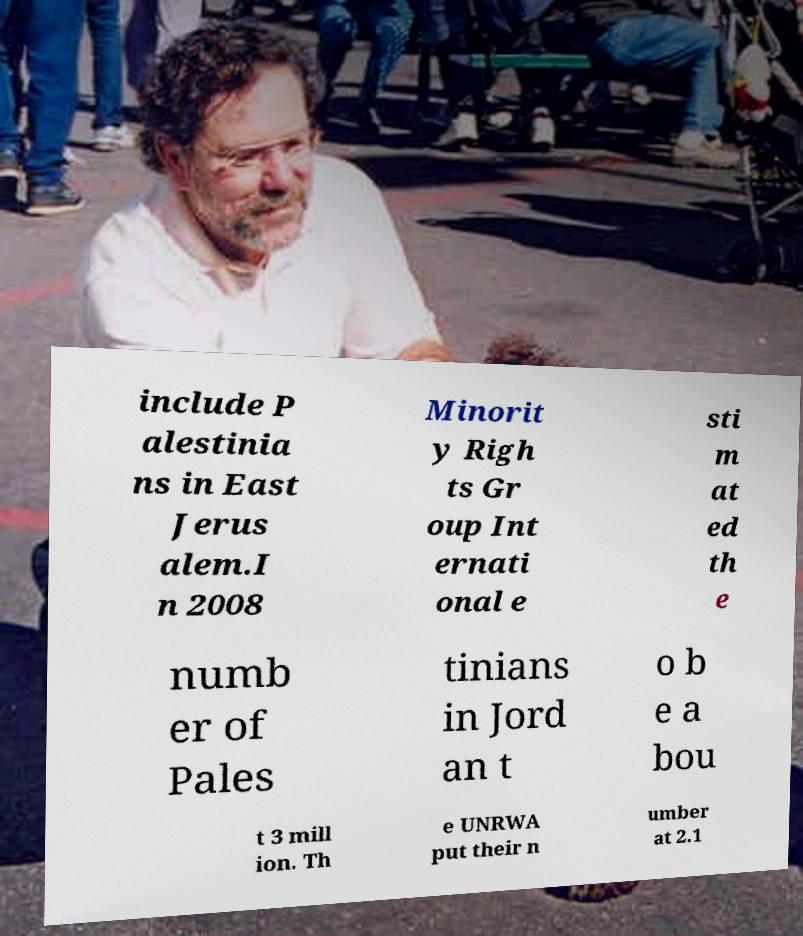Can you read and provide the text displayed in the image?This photo seems to have some interesting text. Can you extract and type it out for me? include P alestinia ns in East Jerus alem.I n 2008 Minorit y Righ ts Gr oup Int ernati onal e sti m at ed th e numb er of Pales tinians in Jord an t o b e a bou t 3 mill ion. Th e UNRWA put their n umber at 2.1 